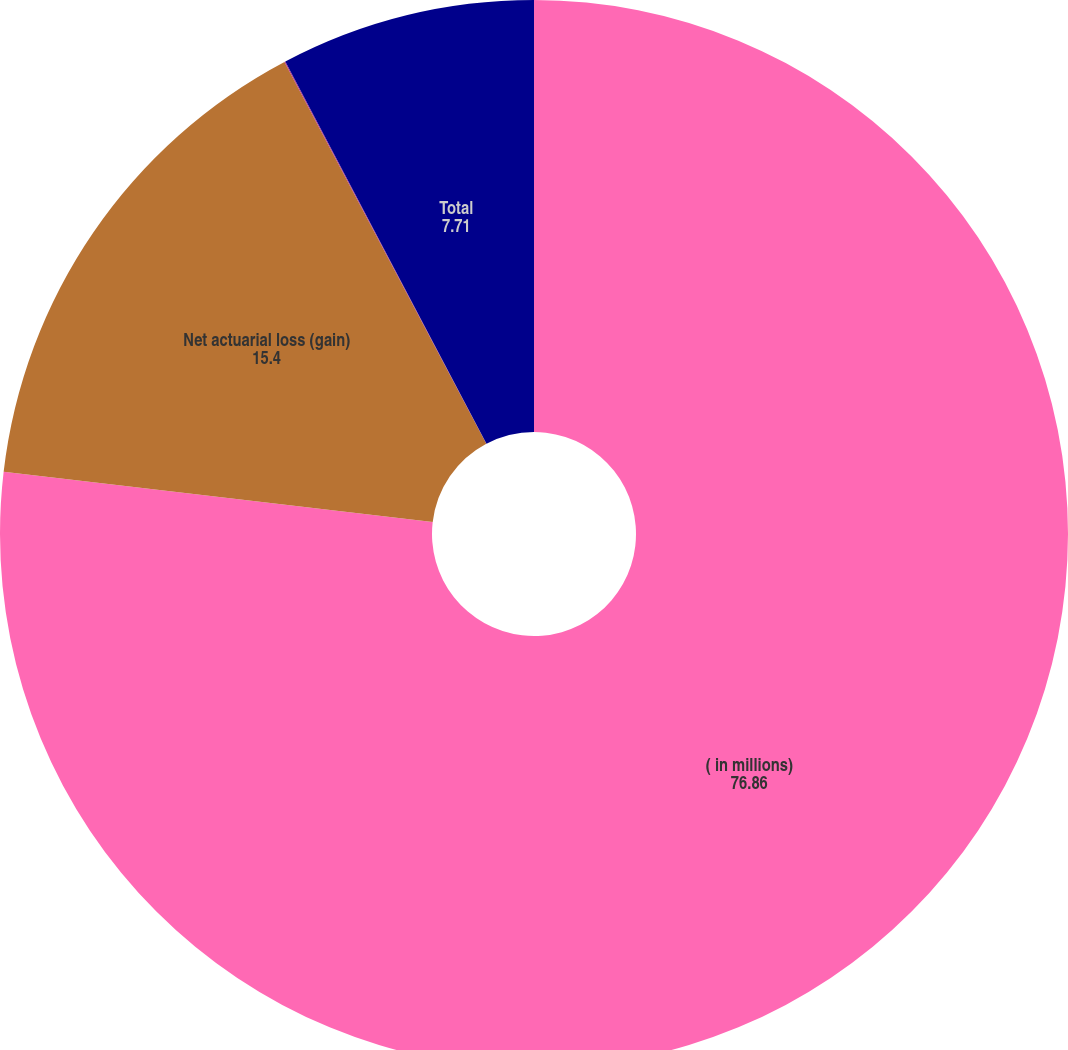Convert chart to OTSL. <chart><loc_0><loc_0><loc_500><loc_500><pie_chart><fcel>( in millions)<fcel>Net actuarial loss (gain)<fcel>Prior service credit<fcel>Total<nl><fcel>76.86%<fcel>15.4%<fcel>0.03%<fcel>7.71%<nl></chart> 